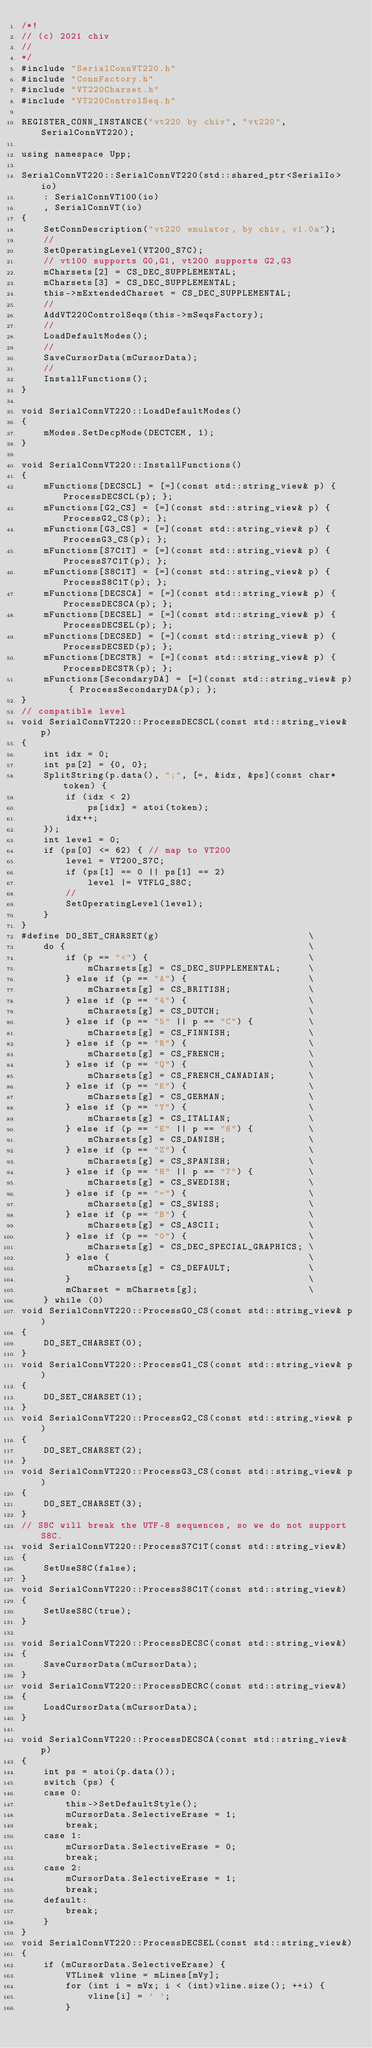<code> <loc_0><loc_0><loc_500><loc_500><_C++_>/*!
// (c) 2021 chiv
//
*/
#include "SerialConnVT220.h"
#include "ConnFactory.h"
#include "VT220Charset.h"
#include "VT220ControlSeq.h"

REGISTER_CONN_INSTANCE("vt220 by chiv", "vt220", SerialConnVT220);

using namespace Upp;

SerialConnVT220::SerialConnVT220(std::shared_ptr<SerialIo> io)
    : SerialConnVT100(io)
    , SerialConnVT(io)
{
    SetConnDescription("vt220 emulator, by chiv, v1.0a");
    //
    SetOperatingLevel(VT200_S7C);
    // vt100 supports G0,G1, vt200 supports G2,G3
    mCharsets[2] = CS_DEC_SUPPLEMENTAL;
    mCharsets[3] = CS_DEC_SUPPLEMENTAL;
    this->mExtendedCharset = CS_DEC_SUPPLEMENTAL;
    //
    AddVT220ControlSeqs(this->mSeqsFactory);
    //
    LoadDefaultModes();
    //
    SaveCursorData(mCursorData);
    //
    InstallFunctions();
}

void SerialConnVT220::LoadDefaultModes()
{
	mModes.SetDecpMode(DECTCEM, 1);
}

void SerialConnVT220::InstallFunctions()
{
    mFunctions[DECSCL] = [=](const std::string_view& p) { ProcessDECSCL(p); };
    mFunctions[G2_CS] = [=](const std::string_view& p) { ProcessG2_CS(p); };
    mFunctions[G3_CS] = [=](const std::string_view& p) { ProcessG3_CS(p); };
    mFunctions[S7C1T] = [=](const std::string_view& p) { ProcessS7C1T(p); };
    mFunctions[S8C1T] = [=](const std::string_view& p) { ProcessS8C1T(p); };
    mFunctions[DECSCA] = [=](const std::string_view& p) { ProcessDECSCA(p); };
    mFunctions[DECSEL] = [=](const std::string_view& p) { ProcessDECSEL(p); };
    mFunctions[DECSED] = [=](const std::string_view& p) { ProcessDECSED(p); };
    mFunctions[DECSTR] = [=](const std::string_view& p) { ProcessDECSTR(p); };
    mFunctions[SecondaryDA] = [=](const std::string_view& p) { ProcessSecondaryDA(p); };
}
// compatible level
void SerialConnVT220::ProcessDECSCL(const std::string_view& p)
{
    int idx = 0;
    int ps[2] = {0, 0};
    SplitString(p.data(), ";", [=, &idx, &ps](const char* token) {
        if (idx < 2)
            ps[idx] = atoi(token);
        idx++;
    });
    int level = 0;
    if (ps[0] <= 62) { // map to VT200
        level = VT200_S7C;
        if (ps[1] == 0 || ps[1] == 2)
            level |= VTFLG_S8C;
        //
        SetOperatingLevel(level);
    }
}
#define DO_SET_CHARSET(g)                           \
    do {                                            \
        if (p == "<") {                             \
            mCharsets[g] = CS_DEC_SUPPLEMENTAL;     \
        } else if (p == "A") {                      \
            mCharsets[g] = CS_BRITISH;              \
        } else if (p == "4") {                      \
            mCharsets[g] = CS_DUTCH;                \
        } else if (p == "5" || p == "C") {          \
            mCharsets[g] = CS_FINNISH;              \
        } else if (p == "R") {                      \
            mCharsets[g] = CS_FRENCH;               \
        } else if (p == "Q") {                      \
            mCharsets[g] = CS_FRENCH_CANADIAN;      \
        } else if (p == "K") {                      \
            mCharsets[g] = CS_GERMAN;               \
        } else if (p == "Y") {                      \
            mCharsets[g] = CS_ITALIAN;              \
        } else if (p == "E" || p == "6") {          \
            mCharsets[g] = CS_DANISH;               \
        } else if (p == "Z") {                      \
            mCharsets[g] = CS_SPANISH;              \
        } else if (p == "H" || p == "7") {          \
            mCharsets[g] = CS_SWEDISH;              \
        } else if (p == "=") {                      \
            mCharsets[g] = CS_SWISS;                \
        } else if (p == "B") {                      \
            mCharsets[g] = CS_ASCII;                \
        } else if (p == "0") {                      \
            mCharsets[g] = CS_DEC_SPECIAL_GRAPHICS; \
        } else {                                    \
            mCharsets[g] = CS_DEFAULT;              \
        }                                           \
        mCharset = mCharsets[g];                    \
    } while (0)
void SerialConnVT220::ProcessG0_CS(const std::string_view& p)
{
    DO_SET_CHARSET(0);
}
void SerialConnVT220::ProcessG1_CS(const std::string_view& p)
{
    DO_SET_CHARSET(1);
}
void SerialConnVT220::ProcessG2_CS(const std::string_view& p)
{
    DO_SET_CHARSET(2);
}
void SerialConnVT220::ProcessG3_CS(const std::string_view& p)
{
    DO_SET_CHARSET(3);
}
// S8C will break the UTF-8 sequences, so we do not support S8C.
void SerialConnVT220::ProcessS7C1T(const std::string_view&)
{
    SetUseS8C(false);
}
void SerialConnVT220::ProcessS8C1T(const std::string_view&)
{
    SetUseS8C(true);
}

void SerialConnVT220::ProcessDECSC(const std::string_view&)
{
    SaveCursorData(mCursorData);
}
void SerialConnVT220::ProcessDECRC(const std::string_view&)
{
    LoadCursorData(mCursorData);
}

void SerialConnVT220::ProcessDECSCA(const std::string_view& p)
{
    int ps = atoi(p.data());
    switch (ps) {
    case 0:
        this->SetDefaultStyle();
        mCursorData.SelectiveErase = 1;
        break;
    case 1:
        mCursorData.SelectiveErase = 0;
        break;
    case 2:
        mCursorData.SelectiveErase = 1;
        break;
    default:
        break;
    }
}
void SerialConnVT220::ProcessDECSEL(const std::string_view&)
{
    if (mCursorData.SelectiveErase) {
        VTLine& vline = mLines[mVy];
        for (int i = mVx; i < (int)vline.size(); ++i) {
            vline[i] = ' ';
        }</code> 